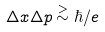<formula> <loc_0><loc_0><loc_500><loc_500>\Delta x \Delta p \stackrel { > } { \sim } \hbar { / } e</formula> 